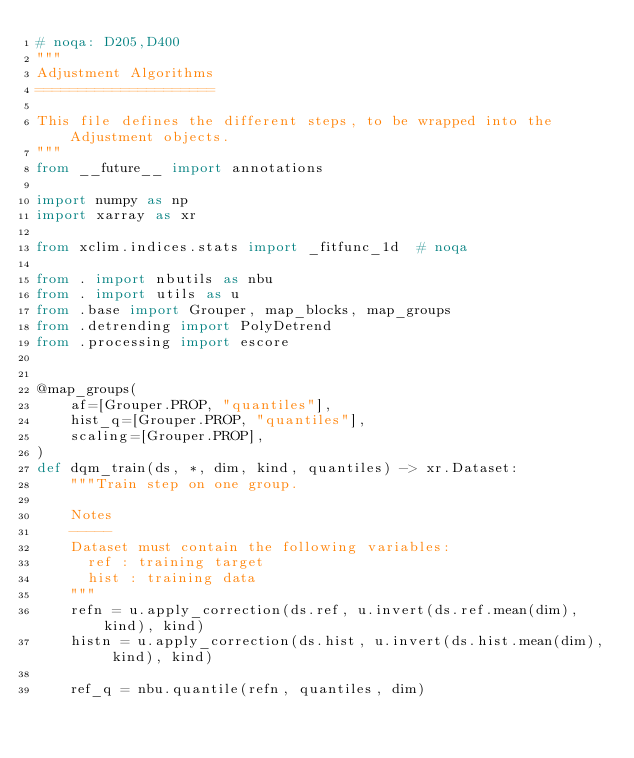Convert code to text. <code><loc_0><loc_0><loc_500><loc_500><_Python_># noqa: D205,D400
"""
Adjustment Algorithms
=====================

This file defines the different steps, to be wrapped into the Adjustment objects.
"""
from __future__ import annotations

import numpy as np
import xarray as xr

from xclim.indices.stats import _fitfunc_1d  # noqa

from . import nbutils as nbu
from . import utils as u
from .base import Grouper, map_blocks, map_groups
from .detrending import PolyDetrend
from .processing import escore


@map_groups(
    af=[Grouper.PROP, "quantiles"],
    hist_q=[Grouper.PROP, "quantiles"],
    scaling=[Grouper.PROP],
)
def dqm_train(ds, *, dim, kind, quantiles) -> xr.Dataset:
    """Train step on one group.

    Notes
    -----
    Dataset must contain the following variables:
      ref : training target
      hist : training data
    """
    refn = u.apply_correction(ds.ref, u.invert(ds.ref.mean(dim), kind), kind)
    histn = u.apply_correction(ds.hist, u.invert(ds.hist.mean(dim), kind), kind)

    ref_q = nbu.quantile(refn, quantiles, dim)</code> 